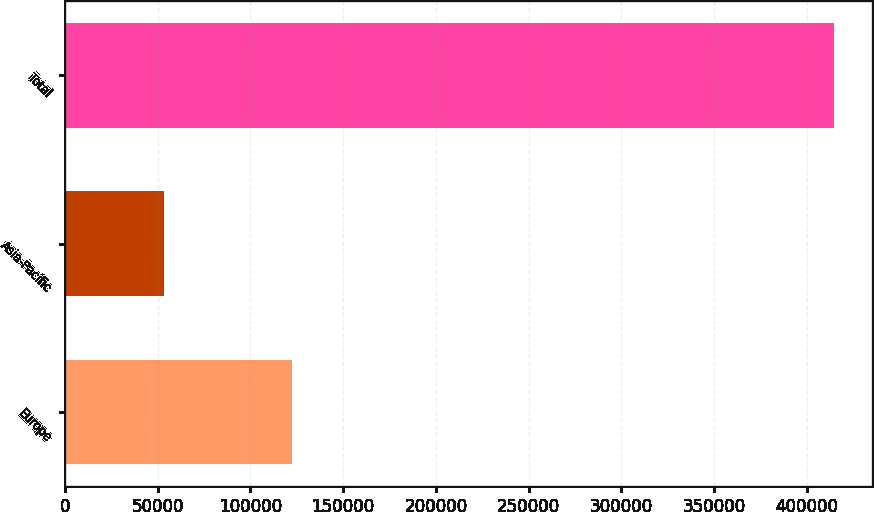<chart> <loc_0><loc_0><loc_500><loc_500><bar_chart><fcel>Europe<fcel>Asia-Pacific<fcel>Total<nl><fcel>122658<fcel>53558<fcel>414799<nl></chart> 